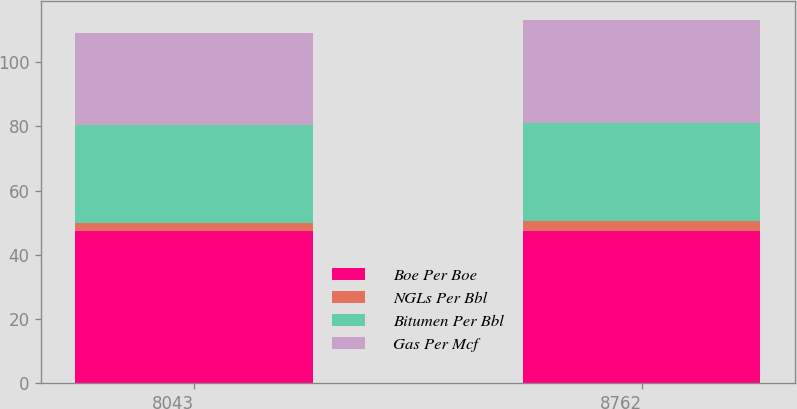<chart> <loc_0><loc_0><loc_500><loc_500><stacked_bar_chart><ecel><fcel>8043<fcel>8762<nl><fcel>Boe Per Boe<fcel>47.57<fcel>47.57<nl><fcel>NGLs Per Bbl<fcel>2.36<fcel>3.01<nl><fcel>Bitumen Per Bbl<fcel>30.42<fcel>30.46<nl><fcel>Gas Per Mcf<fcel>28.65<fcel>32.13<nl></chart> 